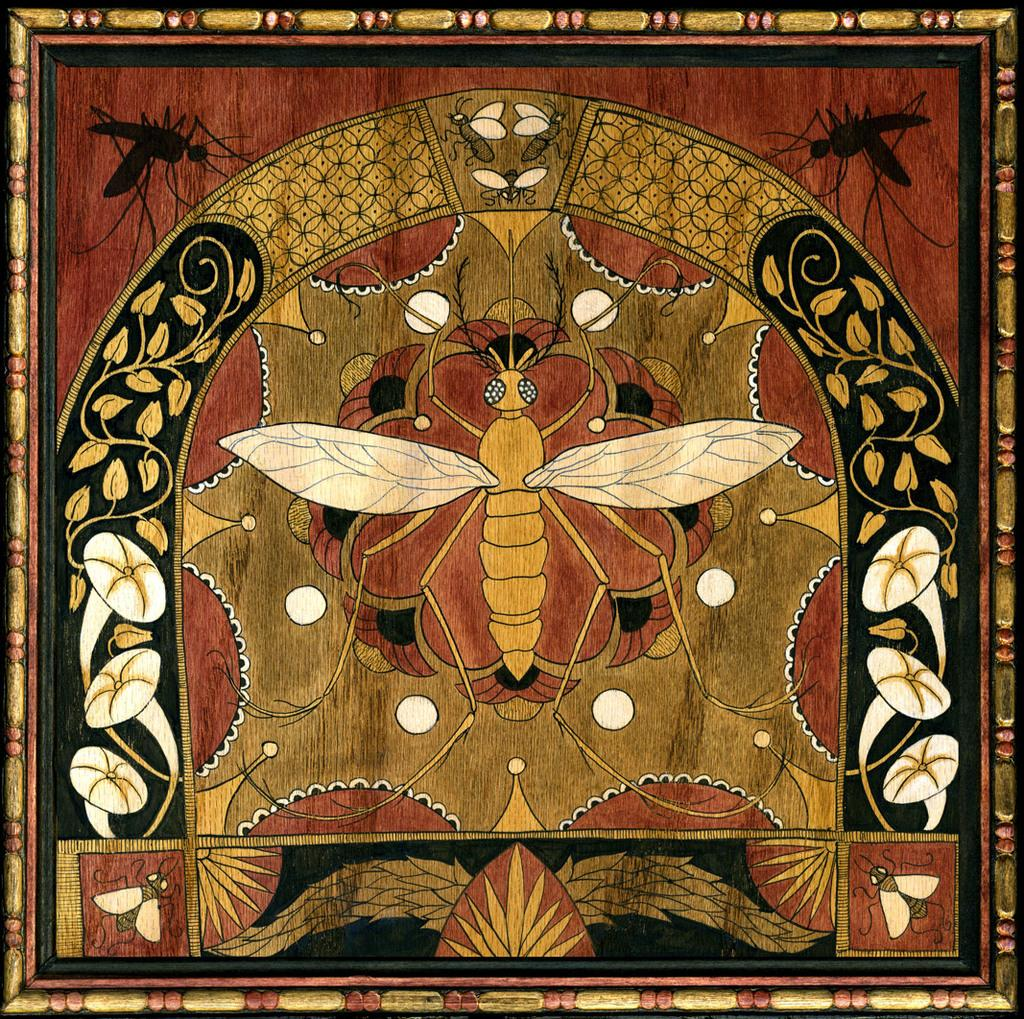What type of artwork is depicted in the image? The image is a painting. What creatures can be seen in the painting? There are insects in the painting. What type of plants are featured in the painting? There are flowers in the painting. Where is the ghost hiding in the painting? There is no ghost present in the painting; it only features insects and flowers. 